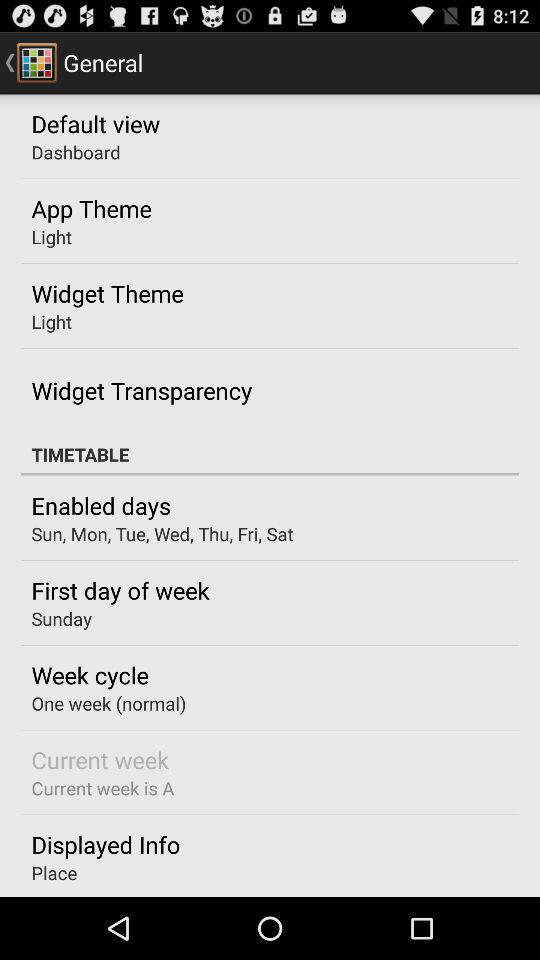What is the first day of the week? The first day of the week is Sunday. 